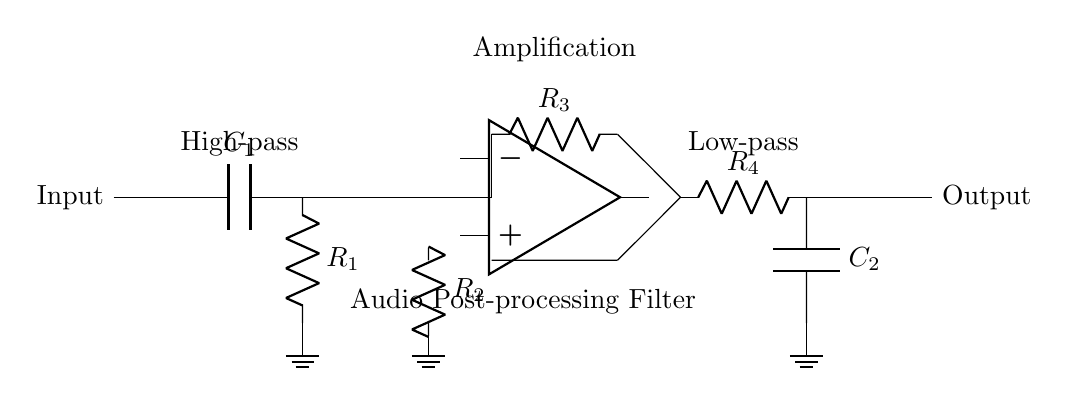What is the purpose of capacitor C1? Capacitor C1 is part of the high-pass filter, which allows higher frequency signals to pass while blocking lower frequency signals.
Answer: High-pass filter What type of components are R1, R2, R3, and R4? R1, R2, R3, and R4 are resistors, which are components that oppose the flow of electric current in a circuit.
Answer: Resistors What is the configuration of the op-amp in this circuit? The op-amp is configured as a non-inverting amplifier, indicated by its connections and the presence of resistors in its feedback loop.
Answer: Non-inverting amplifier Which two components form the low-pass filter? The low-pass filter is formed by resistor R4 and capacitor C2, which allows low frequency signals to pass while attenuating high frequency signals.
Answer: R4 and C2 What does the label "Audio Post-processing Filter" indicate? It indicates that this circuit is designed specifically for processing audio signals, filtering out unwanted frequencies either above or below certain thresholds.
Answer: Audio filter What effect does the combination of the high-pass and low-pass filters have on audio signals? The combination allows for the preservation of a specific frequency range while attenuating both lower and higher frequencies, effectively shaping the audio signal.
Answer: Band-pass effect 